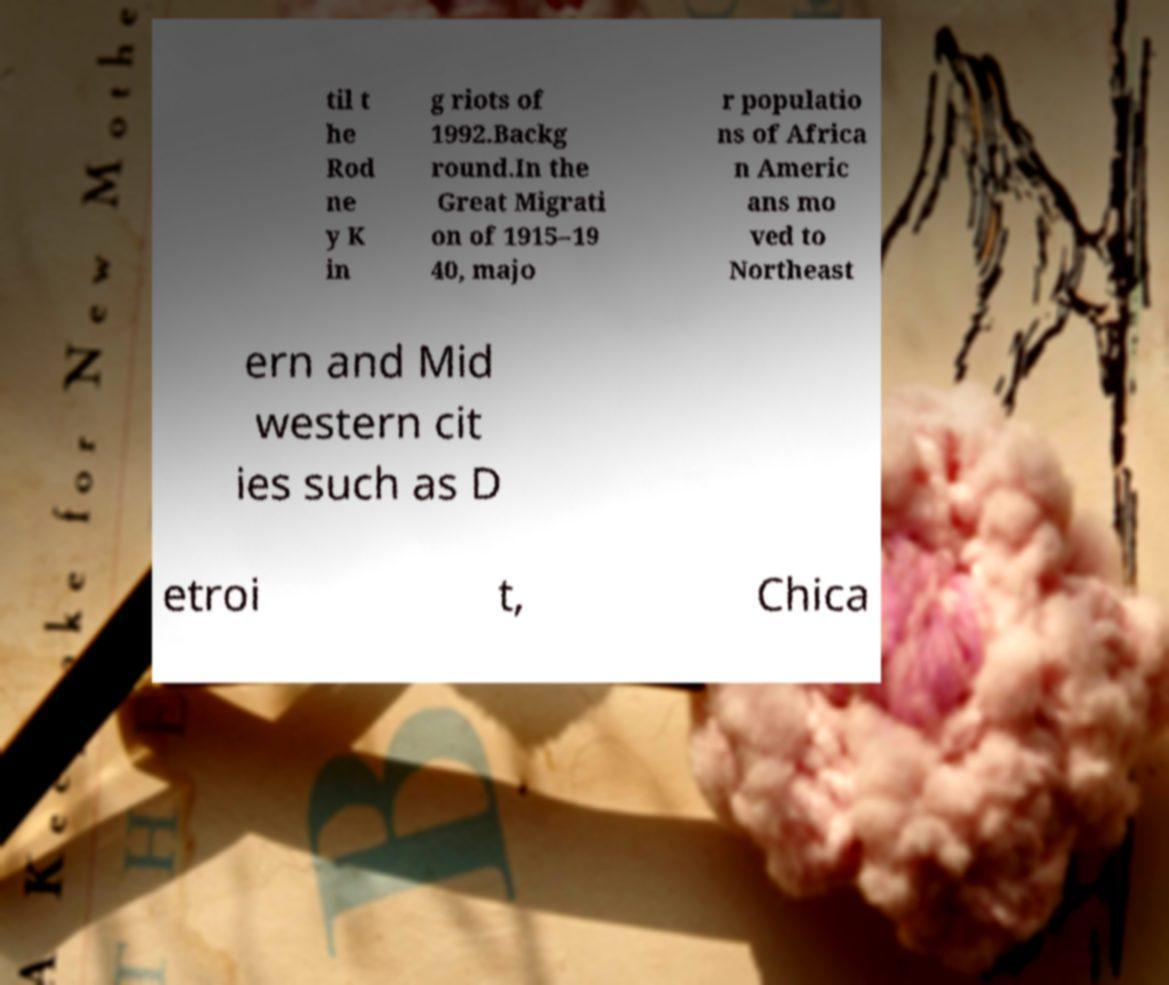There's text embedded in this image that I need extracted. Can you transcribe it verbatim? til t he Rod ne y K in g riots of 1992.Backg round.In the Great Migrati on of 1915–19 40, majo r populatio ns of Africa n Americ ans mo ved to Northeast ern and Mid western cit ies such as D etroi t, Chica 